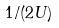<formula> <loc_0><loc_0><loc_500><loc_500>1 / ( 2 U )</formula> 